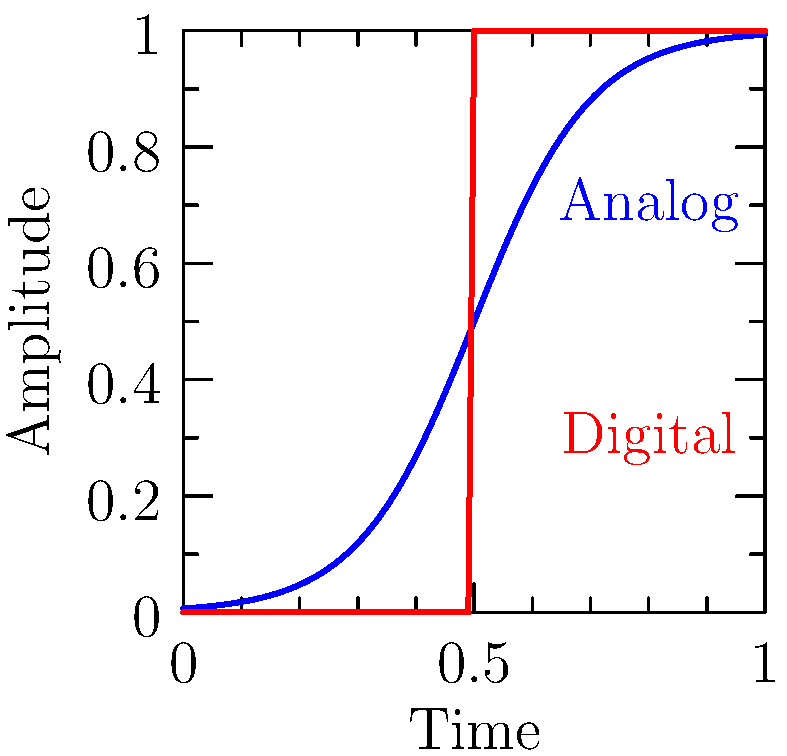Consider the graph representing the transition of an audio signal from low to high amplitude in analog and digital processing. The analog transition is modeled by the function $f(x) = \frac{1}{1+e^{-10(x-0.5)}}$, while the digital transition is a step function. Calculate $\lim_{x \to 0.5^-} [f'(x) - g'(x)]$, where $g(x)$ is the digital step function. How does this limit reflect the difference in smoothness between analog and digital transitions? To solve this problem, let's follow these steps:

1) First, we need to find $f'(x)$:
   $f'(x) = \frac{10e^{-10(x-0.5)}}{(1+e^{-10(x-0.5)})^2}$

2) For $g(x)$, which is a step function:
   $g'(x)$ is undefined at $x=0.5$, and 0 elsewhere.

3) As we approach 0.5 from the left, $g'(x) = 0$.

4) Now, let's calculate the limit:
   $\lim_{x \to 0.5^-} [f'(x) - g'(x)] = \lim_{x \to 0.5^-} f'(x) - \lim_{x \to 0.5^-} g'(x)$

5) $\lim_{x \to 0.5^-} g'(x) = 0$

6) $\lim_{x \to 0.5^-} f'(x) = \frac{10e^{0}}{(1+e^{0})^2} = \frac{10}{4} = 2.5$

7) Therefore, $\lim_{x \to 0.5^-} [f'(x) - g'(x)] = 2.5 - 0 = 2.5$

This non-zero limit reflects the fundamental difference in smoothness between analog and digital transitions. The analog function has a continuous, smooth transition with a defined derivative, while the digital function has an abrupt step with an undefined derivative at the transition point.
Answer: 2.5 